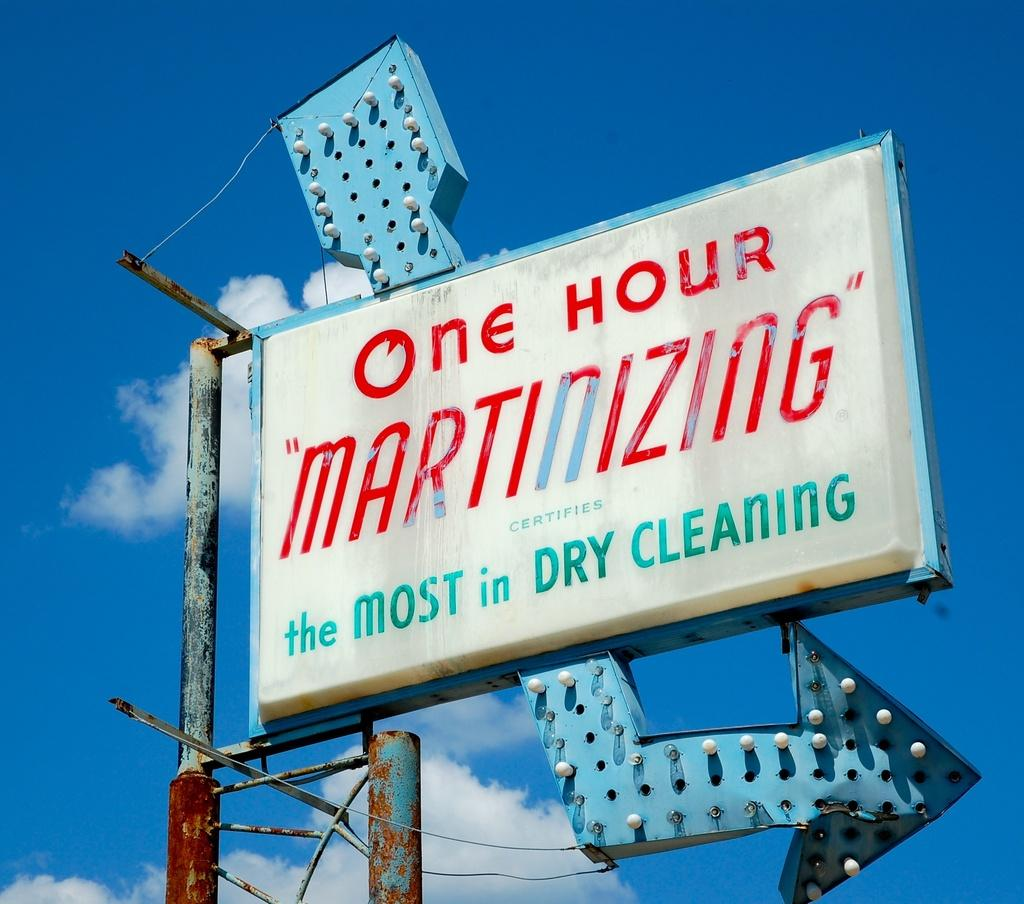<image>
Write a terse but informative summary of the picture. A rusted and worn out billboard for one hour "martinizing" dry cleaning. 